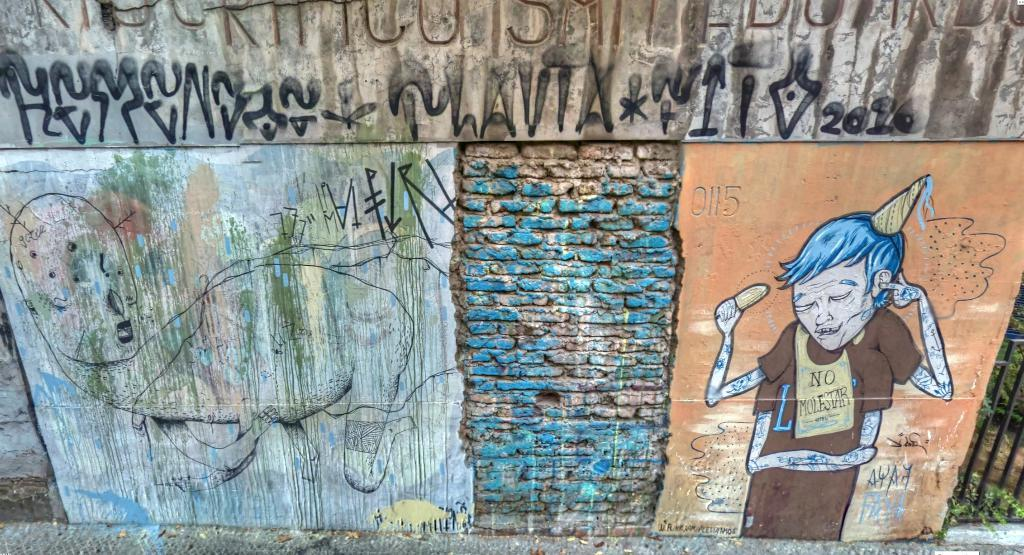What is on the wall in the image? There are paintings and words on the wall in the image. What type of structure can be seen in the image? There are iron grills in the image. What else is present in the image besides the wall and grills? There are plants in the image. Can you see a snail crawling on the iron grills in the image? There is no snail present in the image; it only features paintings, words, iron grills, and plants. What rule is being enforced by the iron grills in the image? The iron grills in the image are not enforcing any rules; they are simply a structural element. 